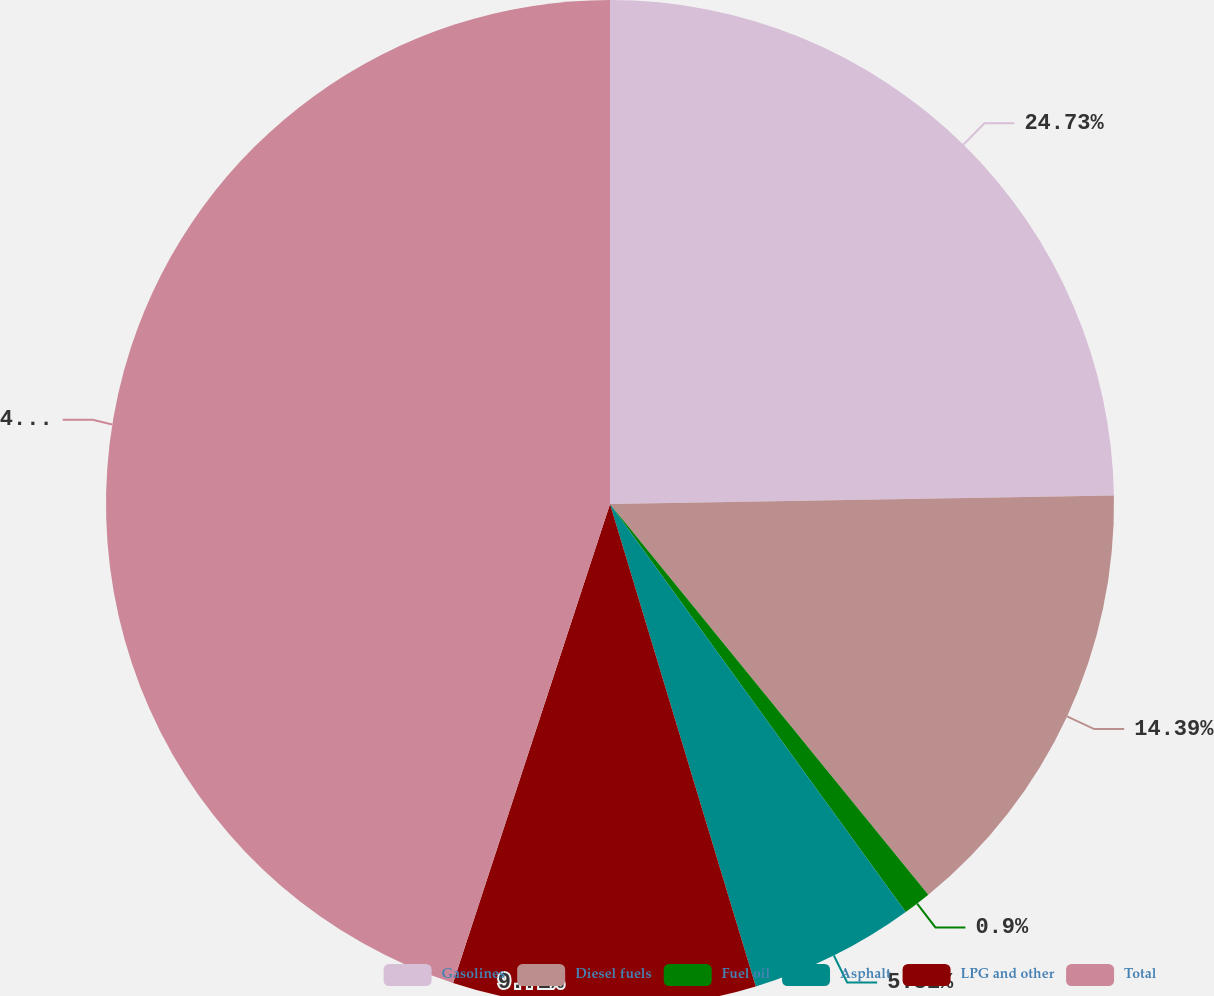Convert chart to OTSL. <chart><loc_0><loc_0><loc_500><loc_500><pie_chart><fcel>Gasolines<fcel>Diesel fuels<fcel>Fuel oil<fcel>Asphalt<fcel>LPG and other<fcel>Total<nl><fcel>24.73%<fcel>14.39%<fcel>0.9%<fcel>5.31%<fcel>9.71%<fcel>44.96%<nl></chart> 